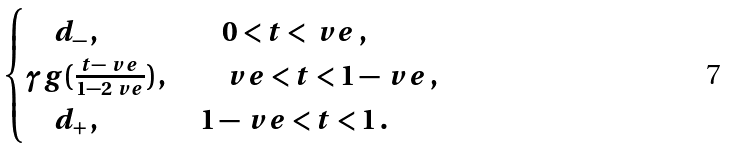Convert formula to latex. <formula><loc_0><loc_0><loc_500><loc_500>\begin{cases} \quad d _ { - } \, , & \quad 0 < t < \ v e \, , \\ \gamma g ( \frac { t - \ v e } { 1 - 2 \ v e } ) \, , & \quad \ v e < t < 1 - \ v e \, , \\ \quad d _ { + } \, , & \ 1 - \ v e < t < 1 \, . \end{cases}</formula> 